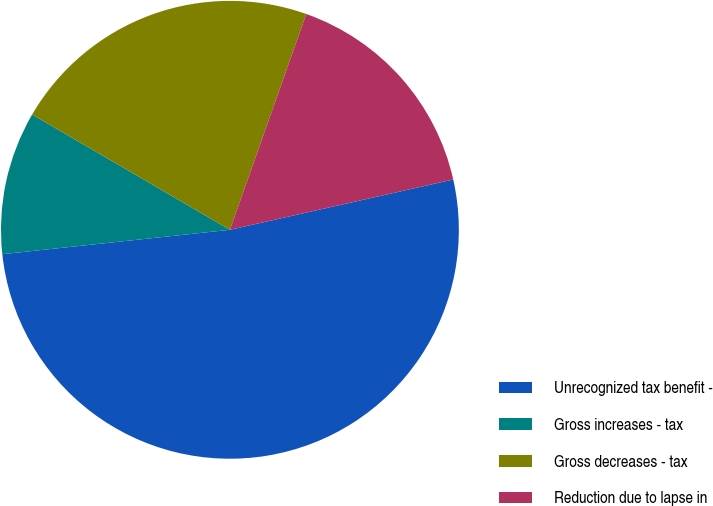Convert chart to OTSL. <chart><loc_0><loc_0><loc_500><loc_500><pie_chart><fcel>Unrecognized tax benefit -<fcel>Gross increases - tax<fcel>Gross decreases - tax<fcel>Reduction due to lapse in<nl><fcel>51.82%<fcel>10.1%<fcel>22.01%<fcel>16.06%<nl></chart> 